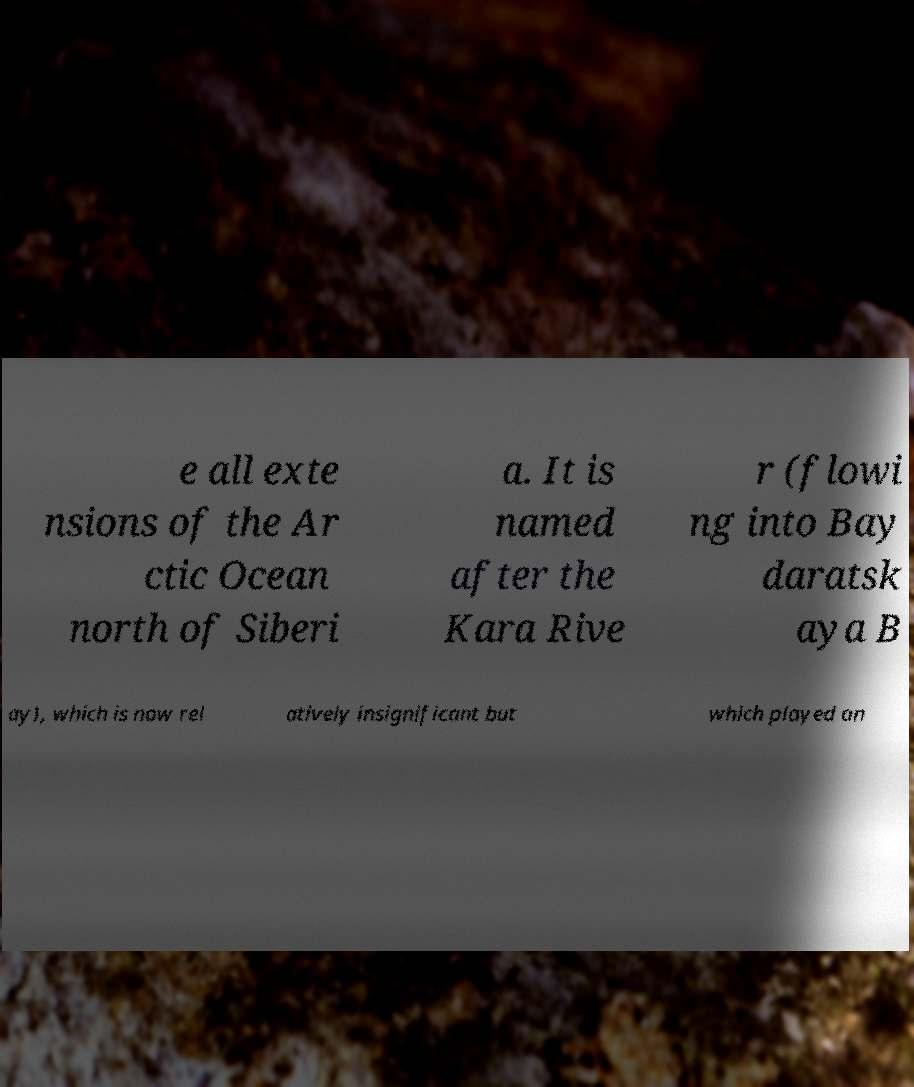There's text embedded in this image that I need extracted. Can you transcribe it verbatim? e all exte nsions of the Ar ctic Ocean north of Siberi a. It is named after the Kara Rive r (flowi ng into Bay daratsk aya B ay), which is now rel atively insignificant but which played an 